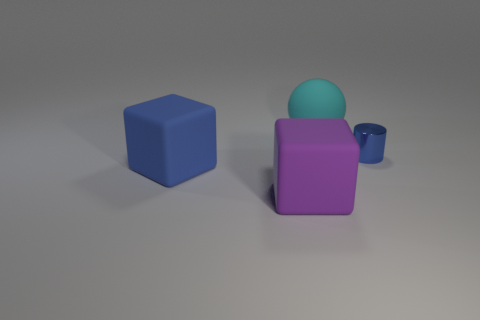Add 4 tiny red cylinders. How many objects exist? 8 Subtract all blue cubes. How many cubes are left? 1 Subtract 1 cylinders. How many cylinders are left? 0 Subtract all tiny objects. Subtract all rubber cubes. How many objects are left? 1 Add 2 large purple rubber objects. How many large purple rubber objects are left? 3 Add 2 blue matte blocks. How many blue matte blocks exist? 3 Subtract 0 gray spheres. How many objects are left? 4 Subtract all purple cylinders. Subtract all green balls. How many cylinders are left? 1 Subtract all red cylinders. How many yellow spheres are left? 0 